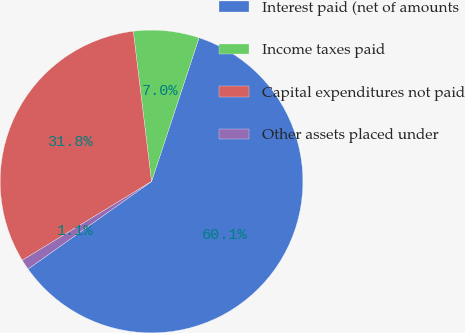Convert chart. <chart><loc_0><loc_0><loc_500><loc_500><pie_chart><fcel>Interest paid (net of amounts<fcel>Income taxes paid<fcel>Capital expenditures not paid<fcel>Other assets placed under<nl><fcel>60.1%<fcel>7.01%<fcel>31.79%<fcel>1.11%<nl></chart> 